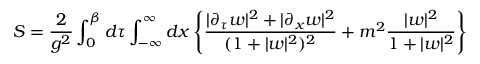Convert formula to latex. <formula><loc_0><loc_0><loc_500><loc_500>S = { \frac { 2 } { g ^ { 2 } } } \int _ { 0 } ^ { \beta } d \tau \int _ { - \infty } ^ { \infty } d x \left \{ { \frac { | \partial _ { \tau } w | ^ { 2 } + | \partial _ { x } w | ^ { 2 } } { ( 1 + | w | ^ { 2 } ) ^ { 2 } } } + m ^ { 2 } { \frac { | w | ^ { 2 } } { 1 + | w | ^ { 2 } } } \right \}</formula> 